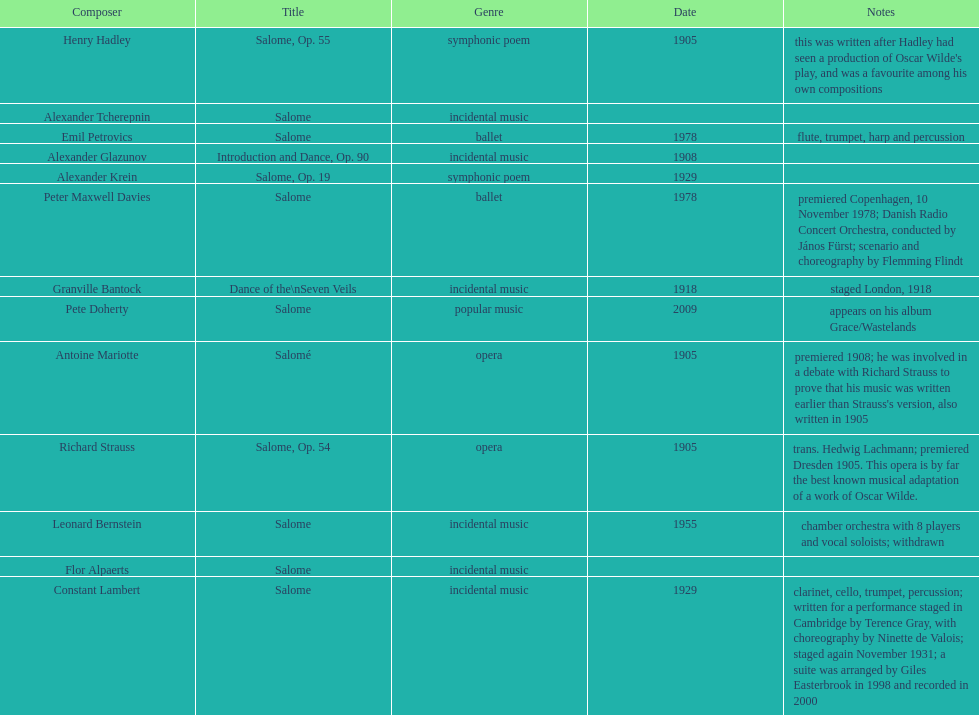How many works were made in the incidental music genre? 6. Parse the full table. {'header': ['Composer', 'Title', 'Genre', 'Date', 'Notes'], 'rows': [['Henry Hadley', 'Salome, Op. 55', 'symphonic poem', '1905', "this was written after Hadley had seen a production of Oscar Wilde's play, and was a favourite among his own compositions"], ['Alexander\xa0Tcherepnin', 'Salome', 'incidental music', '', ''], ['Emil Petrovics', 'Salome', 'ballet', '1978', 'flute, trumpet, harp and percussion'], ['Alexander Glazunov', 'Introduction and Dance, Op. 90', 'incidental music', '1908', ''], ['Alexander Krein', 'Salome, Op. 19', 'symphonic poem', '1929', ''], ['Peter\xa0Maxwell\xa0Davies', 'Salome', 'ballet', '1978', 'premiered Copenhagen, 10 November 1978; Danish Radio Concert Orchestra, conducted by János Fürst; scenario and choreography by Flemming Flindt'], ['Granville Bantock', 'Dance of the\\nSeven Veils', 'incidental music', '1918', 'staged London, 1918'], ['Pete Doherty', 'Salome', 'popular music', '2009', 'appears on his album Grace/Wastelands'], ['Antoine Mariotte', 'Salomé', 'opera', '1905', "premiered 1908; he was involved in a debate with Richard Strauss to prove that his music was written earlier than Strauss's version, also written in 1905"], ['Richard Strauss', 'Salome, Op. 54', 'opera', '1905', 'trans. Hedwig Lachmann; premiered Dresden 1905. This opera is by far the best known musical adaptation of a work of Oscar Wilde.'], ['Leonard Bernstein', 'Salome', 'incidental music', '1955', 'chamber orchestra with 8 players and vocal soloists; withdrawn'], ['Flor Alpaerts', 'Salome', 'incidental\xa0music', '', ''], ['Constant Lambert', 'Salome', 'incidental music', '1929', 'clarinet, cello, trumpet, percussion; written for a performance staged in Cambridge by Terence Gray, with choreography by Ninette de Valois; staged again November 1931; a suite was arranged by Giles Easterbrook in 1998 and recorded in 2000']]} 